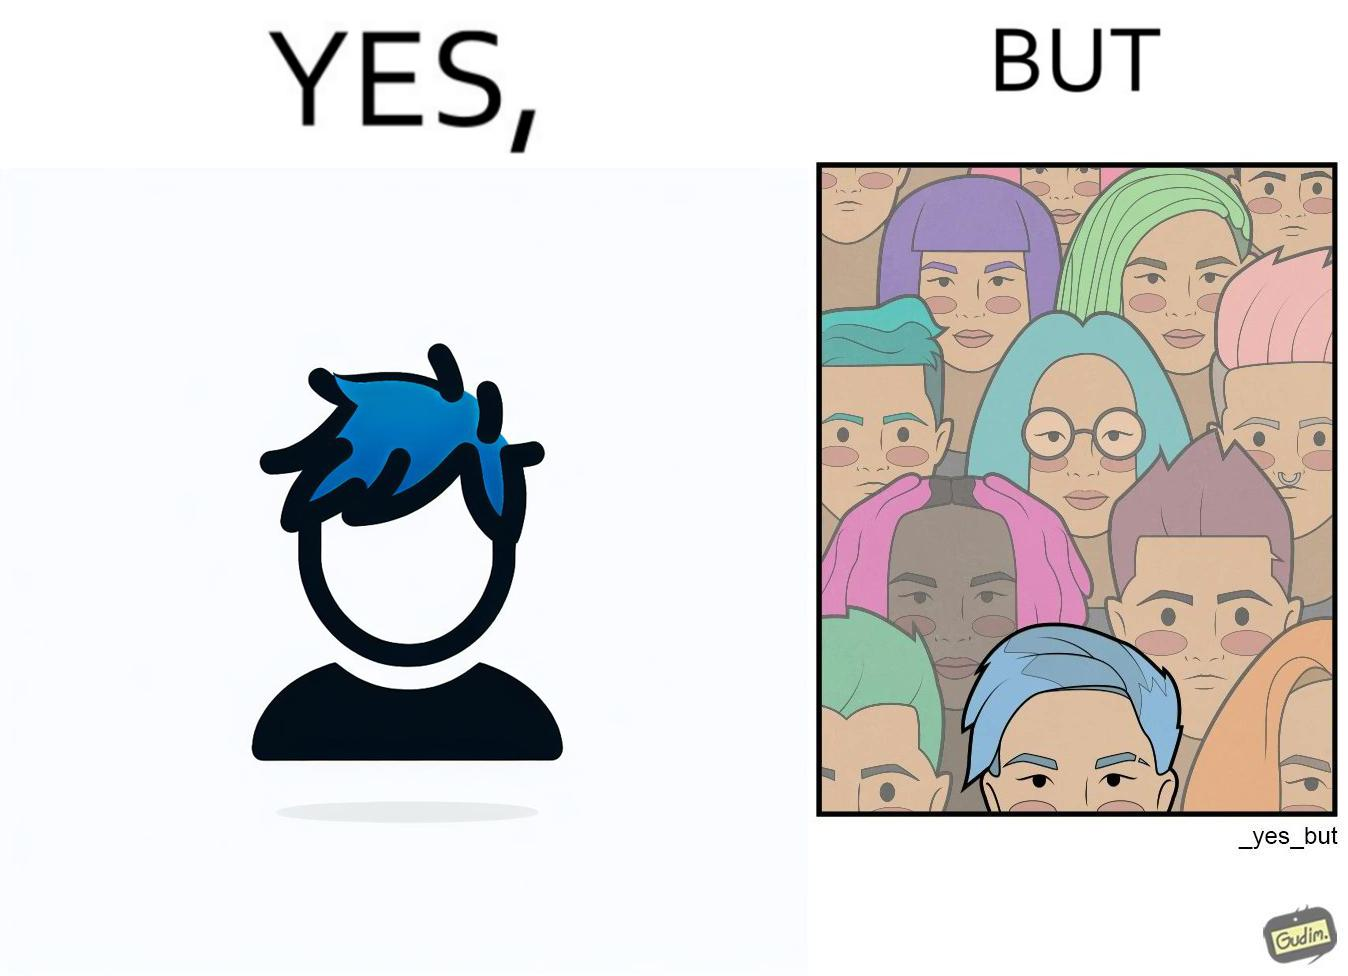Describe the satirical element in this image. The image is funny, as one person with a hair dyed blue seems to symbolize that the person is going against the grain, however, when we zoom out, the group of people have hair dyed in several, different colors, showing that, dyeing hair is the new normal. 